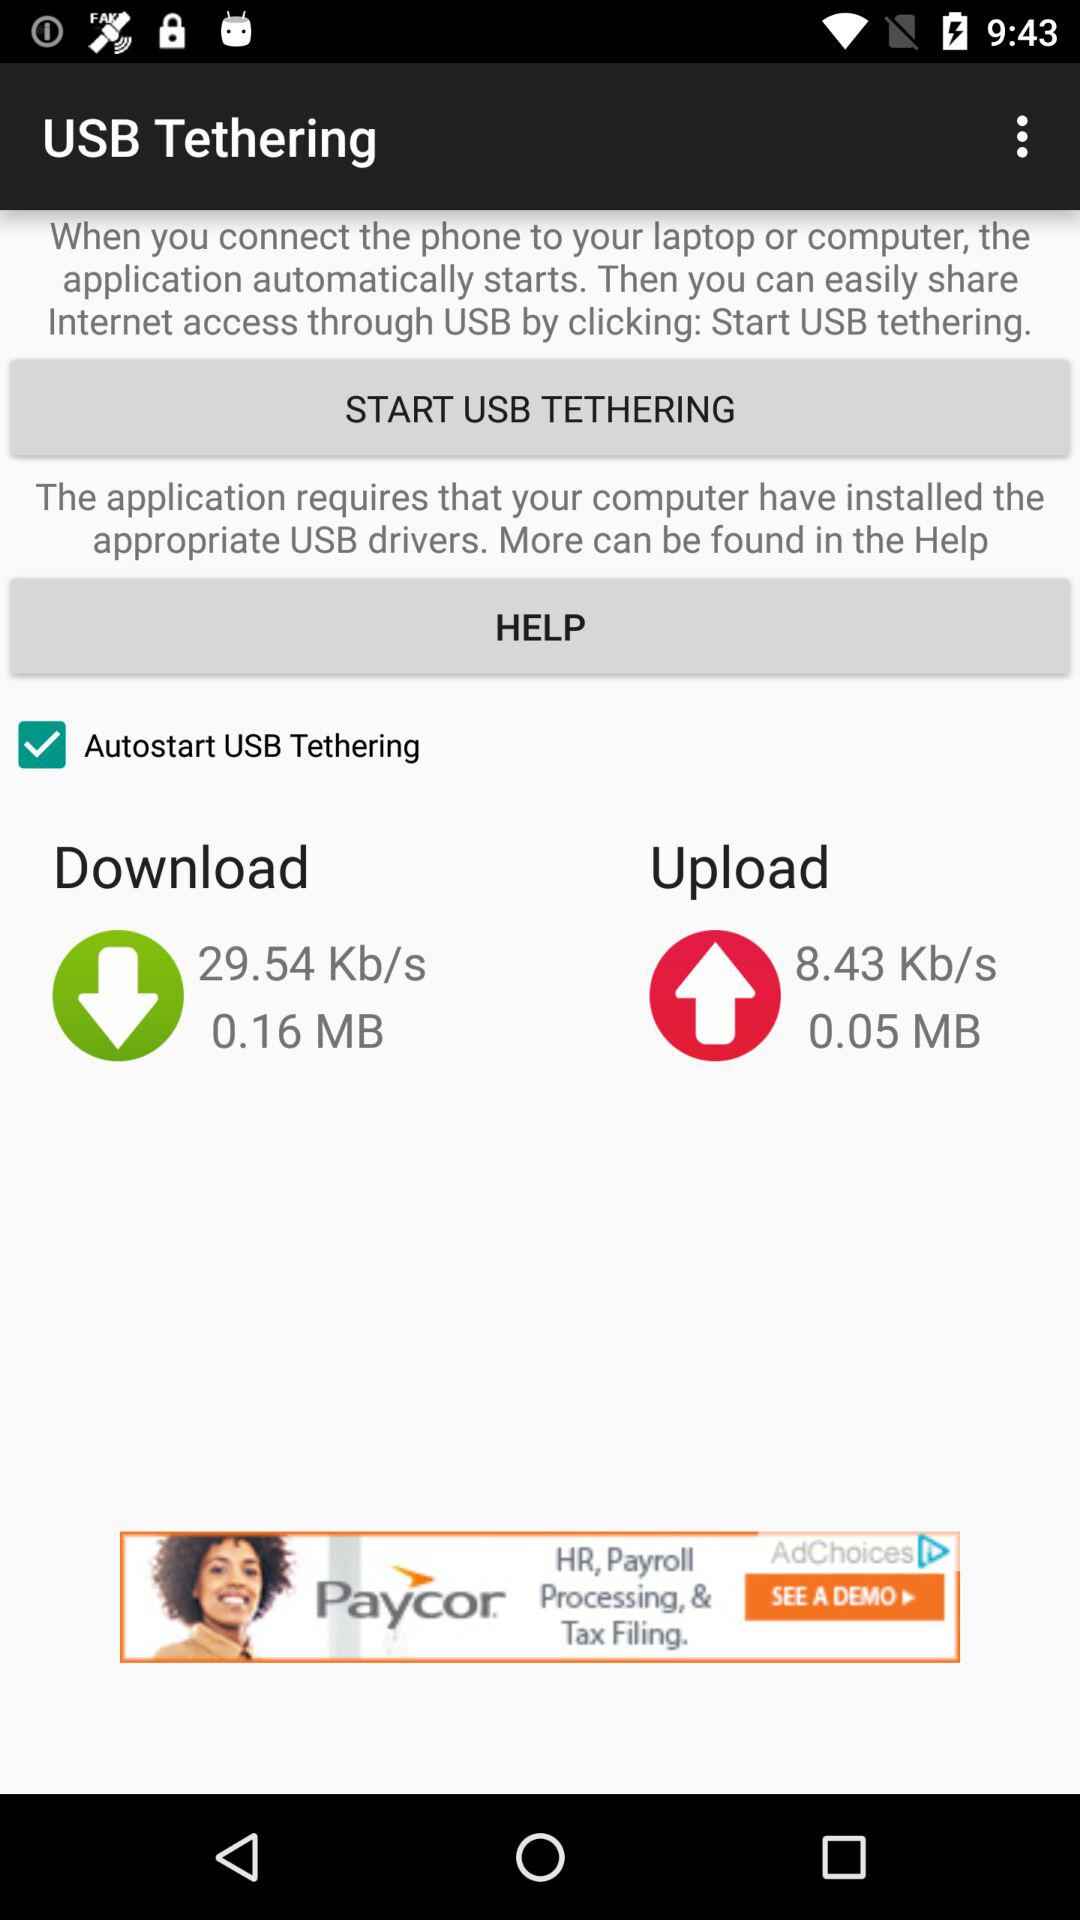How many MB are uploaded? There is 0.16 MB that has been uploaded. 